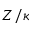<formula> <loc_0><loc_0><loc_500><loc_500>Z / \kappa</formula> 